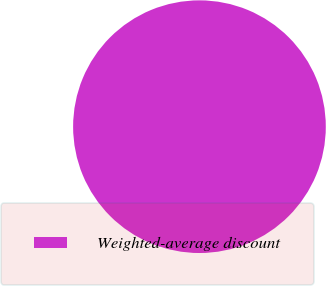Convert chart to OTSL. <chart><loc_0><loc_0><loc_500><loc_500><pie_chart><fcel>Weighted-average discount<nl><fcel>100.0%<nl></chart> 